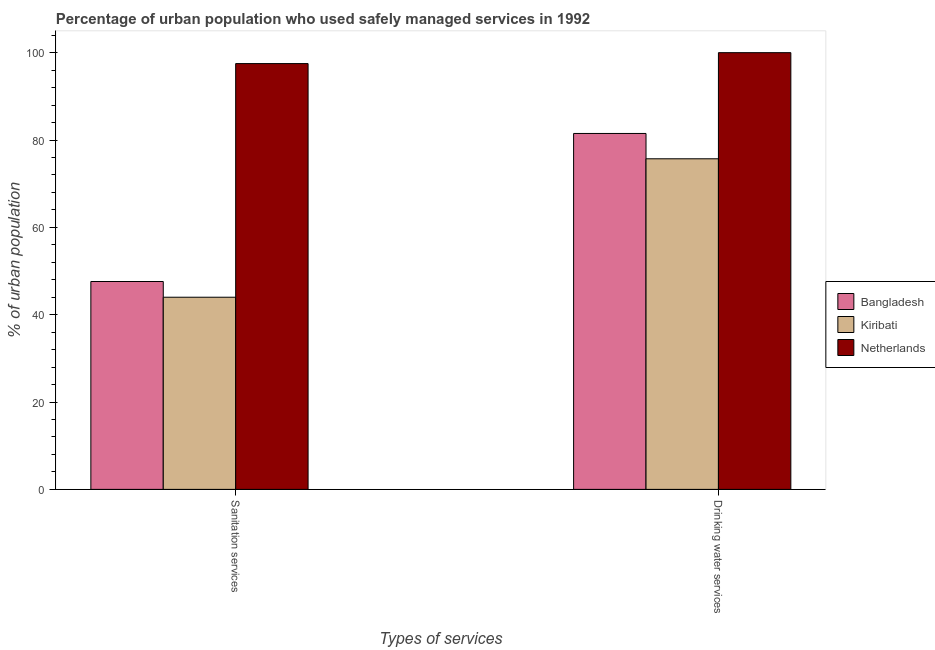How many bars are there on the 1st tick from the right?
Offer a terse response. 3. What is the label of the 2nd group of bars from the left?
Ensure brevity in your answer.  Drinking water services. Across all countries, what is the minimum percentage of urban population who used drinking water services?
Offer a very short reply. 75.7. In which country was the percentage of urban population who used drinking water services minimum?
Offer a terse response. Kiribati. What is the total percentage of urban population who used drinking water services in the graph?
Your answer should be very brief. 257.2. What is the difference between the percentage of urban population who used sanitation services in Netherlands and that in Kiribati?
Give a very brief answer. 53.5. What is the difference between the percentage of urban population who used drinking water services in Netherlands and the percentage of urban population who used sanitation services in Bangladesh?
Ensure brevity in your answer.  52.4. What is the average percentage of urban population who used sanitation services per country?
Offer a very short reply. 63.03. What is the difference between the percentage of urban population who used sanitation services and percentage of urban population who used drinking water services in Netherlands?
Offer a very short reply. -2.5. What is the ratio of the percentage of urban population who used sanitation services in Kiribati to that in Netherlands?
Offer a very short reply. 0.45. In how many countries, is the percentage of urban population who used sanitation services greater than the average percentage of urban population who used sanitation services taken over all countries?
Offer a terse response. 1. What does the 2nd bar from the left in Drinking water services represents?
Offer a very short reply. Kiribati. What does the 1st bar from the right in Drinking water services represents?
Give a very brief answer. Netherlands. Are all the bars in the graph horizontal?
Ensure brevity in your answer.  No. Are the values on the major ticks of Y-axis written in scientific E-notation?
Offer a very short reply. No. Does the graph contain any zero values?
Offer a very short reply. No. Does the graph contain grids?
Provide a succinct answer. No. What is the title of the graph?
Keep it short and to the point. Percentage of urban population who used safely managed services in 1992. Does "Cyprus" appear as one of the legend labels in the graph?
Your response must be concise. No. What is the label or title of the X-axis?
Provide a succinct answer. Types of services. What is the label or title of the Y-axis?
Offer a very short reply. % of urban population. What is the % of urban population of Bangladesh in Sanitation services?
Offer a very short reply. 47.6. What is the % of urban population of Netherlands in Sanitation services?
Your answer should be compact. 97.5. What is the % of urban population in Bangladesh in Drinking water services?
Your answer should be very brief. 81.5. What is the % of urban population in Kiribati in Drinking water services?
Provide a succinct answer. 75.7. Across all Types of services, what is the maximum % of urban population of Bangladesh?
Ensure brevity in your answer.  81.5. Across all Types of services, what is the maximum % of urban population of Kiribati?
Offer a terse response. 75.7. Across all Types of services, what is the maximum % of urban population in Netherlands?
Keep it short and to the point. 100. Across all Types of services, what is the minimum % of urban population of Bangladesh?
Offer a terse response. 47.6. Across all Types of services, what is the minimum % of urban population of Netherlands?
Offer a very short reply. 97.5. What is the total % of urban population in Bangladesh in the graph?
Provide a succinct answer. 129.1. What is the total % of urban population of Kiribati in the graph?
Keep it short and to the point. 119.7. What is the total % of urban population of Netherlands in the graph?
Offer a very short reply. 197.5. What is the difference between the % of urban population of Bangladesh in Sanitation services and that in Drinking water services?
Your answer should be compact. -33.9. What is the difference between the % of urban population in Kiribati in Sanitation services and that in Drinking water services?
Provide a succinct answer. -31.7. What is the difference between the % of urban population in Bangladesh in Sanitation services and the % of urban population in Kiribati in Drinking water services?
Provide a succinct answer. -28.1. What is the difference between the % of urban population of Bangladesh in Sanitation services and the % of urban population of Netherlands in Drinking water services?
Offer a very short reply. -52.4. What is the difference between the % of urban population of Kiribati in Sanitation services and the % of urban population of Netherlands in Drinking water services?
Your response must be concise. -56. What is the average % of urban population in Bangladesh per Types of services?
Your answer should be compact. 64.55. What is the average % of urban population of Kiribati per Types of services?
Your answer should be compact. 59.85. What is the average % of urban population of Netherlands per Types of services?
Your response must be concise. 98.75. What is the difference between the % of urban population in Bangladesh and % of urban population in Kiribati in Sanitation services?
Offer a terse response. 3.6. What is the difference between the % of urban population of Bangladesh and % of urban population of Netherlands in Sanitation services?
Provide a short and direct response. -49.9. What is the difference between the % of urban population in Kiribati and % of urban population in Netherlands in Sanitation services?
Provide a succinct answer. -53.5. What is the difference between the % of urban population of Bangladesh and % of urban population of Netherlands in Drinking water services?
Your answer should be very brief. -18.5. What is the difference between the % of urban population in Kiribati and % of urban population in Netherlands in Drinking water services?
Give a very brief answer. -24.3. What is the ratio of the % of urban population in Bangladesh in Sanitation services to that in Drinking water services?
Provide a succinct answer. 0.58. What is the ratio of the % of urban population of Kiribati in Sanitation services to that in Drinking water services?
Ensure brevity in your answer.  0.58. What is the difference between the highest and the second highest % of urban population in Bangladesh?
Your answer should be very brief. 33.9. What is the difference between the highest and the second highest % of urban population in Kiribati?
Your response must be concise. 31.7. What is the difference between the highest and the lowest % of urban population of Bangladesh?
Provide a short and direct response. 33.9. What is the difference between the highest and the lowest % of urban population in Kiribati?
Keep it short and to the point. 31.7. 